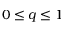Convert formula to latex. <formula><loc_0><loc_0><loc_500><loc_500>0 \leq q \leq 1</formula> 